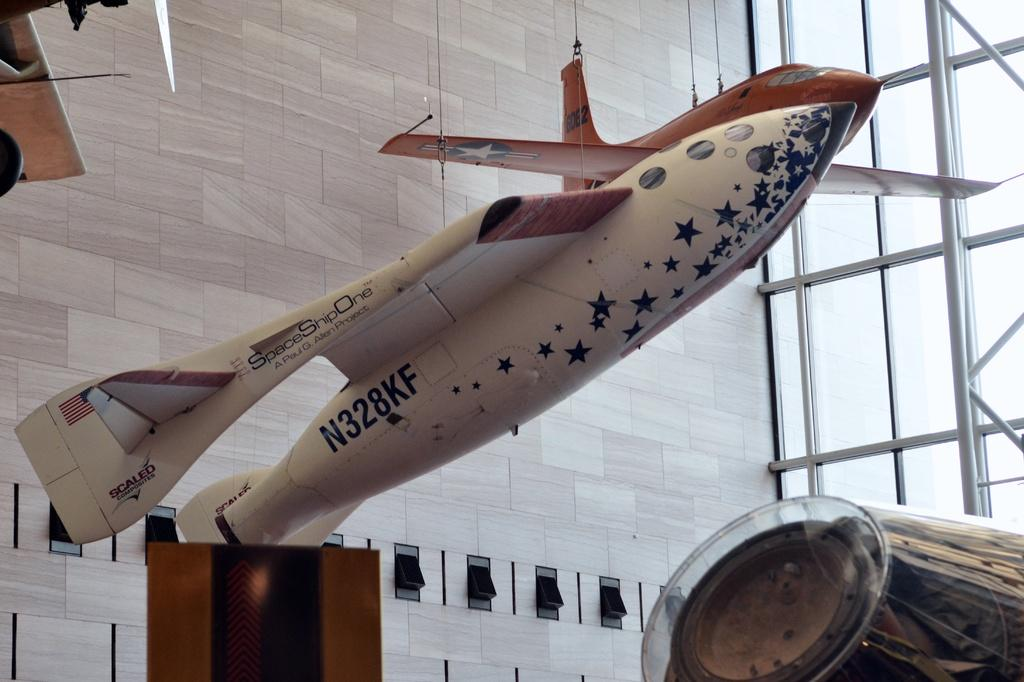<image>
Write a terse but informative summary of the picture. SpaceShipOne plane from A Paul G. Allen Project. 